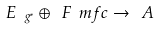Convert formula to latex. <formula><loc_0><loc_0><loc_500><loc_500>E _ { \ g ^ { * } } \oplus \ F \ m f { c } \to \ A</formula> 